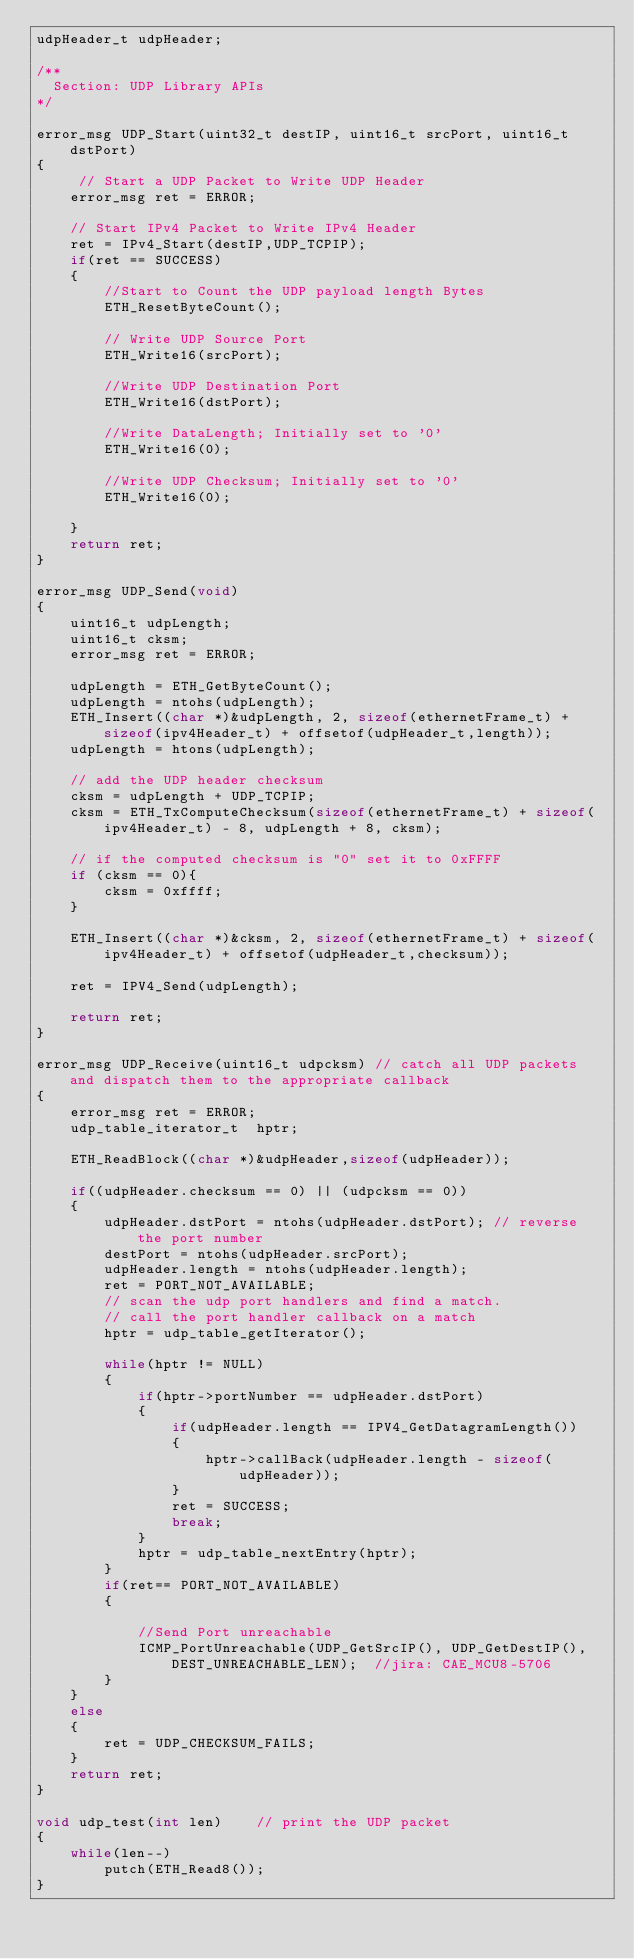Convert code to text. <code><loc_0><loc_0><loc_500><loc_500><_C_>udpHeader_t udpHeader;

/**
  Section: UDP Library APIs
*/

error_msg UDP_Start(uint32_t destIP, uint16_t srcPort, uint16_t dstPort)
{
     // Start a UDP Packet to Write UDP Header
    error_msg ret = ERROR;

    // Start IPv4 Packet to Write IPv4 Header
    ret = IPv4_Start(destIP,UDP_TCPIP);
    if(ret == SUCCESS)
    {
        //Start to Count the UDP payload length Bytes
        ETH_ResetByteCount();

        // Write UDP Source Port
        ETH_Write16(srcPort);

        //Write UDP Destination Port
        ETH_Write16(dstPort);

        //Write DataLength; Initially set to '0'
        ETH_Write16(0);

        //Write UDP Checksum; Initially set to '0'
        ETH_Write16(0);

    }
    return ret;
}

error_msg UDP_Send(void)
{
    uint16_t udpLength;
    uint16_t cksm;
    error_msg ret = ERROR;

    udpLength = ETH_GetByteCount();
    udpLength = ntohs(udpLength);
    ETH_Insert((char *)&udpLength, 2, sizeof(ethernetFrame_t) + sizeof(ipv4Header_t) + offsetof(udpHeader_t,length));
    udpLength = htons(udpLength);
    
    // add the UDP header checksum
    cksm = udpLength + UDP_TCPIP;
    cksm = ETH_TxComputeChecksum(sizeof(ethernetFrame_t) + sizeof(ipv4Header_t) - 8, udpLength + 8, cksm);

    // if the computed checksum is "0" set it to 0xFFFF
    if (cksm == 0){
        cksm = 0xffff;
    }

    ETH_Insert((char *)&cksm, 2, sizeof(ethernetFrame_t) + sizeof(ipv4Header_t) + offsetof(udpHeader_t,checksum));

    ret = IPV4_Send(udpLength);

    return ret;
}

error_msg UDP_Receive(uint16_t udpcksm) // catch all UDP packets and dispatch them to the appropriate callback
{
    error_msg ret = ERROR;
    udp_table_iterator_t  hptr;

    ETH_ReadBlock((char *)&udpHeader,sizeof(udpHeader));

    if((udpHeader.checksum == 0) || (udpcksm == 0))
    {
        udpHeader.dstPort = ntohs(udpHeader.dstPort); // reverse the port number
        destPort = ntohs(udpHeader.srcPort);
        udpHeader.length = ntohs(udpHeader.length);
        ret = PORT_NOT_AVAILABLE;
        // scan the udp port handlers and find a match.
        // call the port handler callback on a match
        hptr = udp_table_getIterator();
        
        while(hptr != NULL)
        {
            if(hptr->portNumber == udpHeader.dstPort)
            {          
                if(udpHeader.length == IPV4_GetDatagramLength())
                {
                    hptr->callBack(udpHeader.length - sizeof(udpHeader));                    
                }
                ret = SUCCESS;
                break;
            }
            hptr = udp_table_nextEntry(hptr);
        }
        if(ret== PORT_NOT_AVAILABLE)
        {
            
            //Send Port unreachable                
            ICMP_PortUnreachable(UDP_GetSrcIP(), UDP_GetDestIP(), DEST_UNREACHABLE_LEN);  //jira: CAE_MCU8-5706
        }
    }
    else
    {
        ret = UDP_CHECKSUM_FAILS;
    }
    return ret;
}

void udp_test(int len)    // print the UDP packet
{
    while(len--)
        putch(ETH_Read8());
}
</code> 